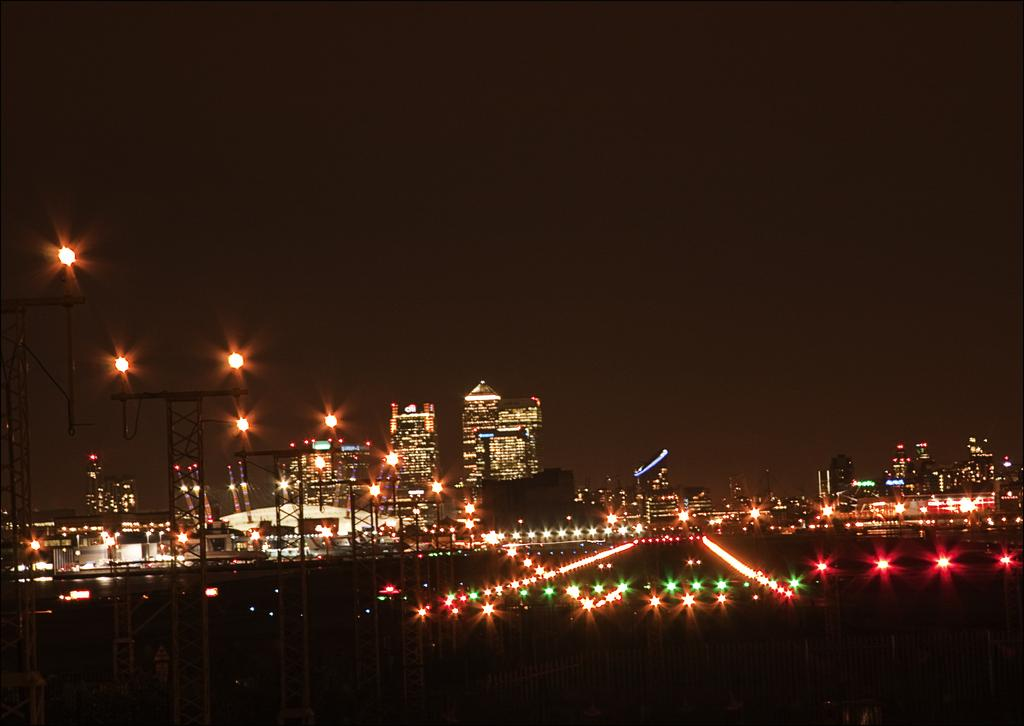What can be seen on the left side of the image? There are poles on the left side of the image. What is located in the center of the image? There are lights in the center of the image. What type of structures are visible in the background of the image? There are buildings in the background of the image. What is the tendency of the lights to change color over time in the image? There is no information about the lights changing color or any time-related aspect in the image. How many people are pushing the buildings in the image? There are no people pushing the buildings in the image, and the buildings are stationary. 